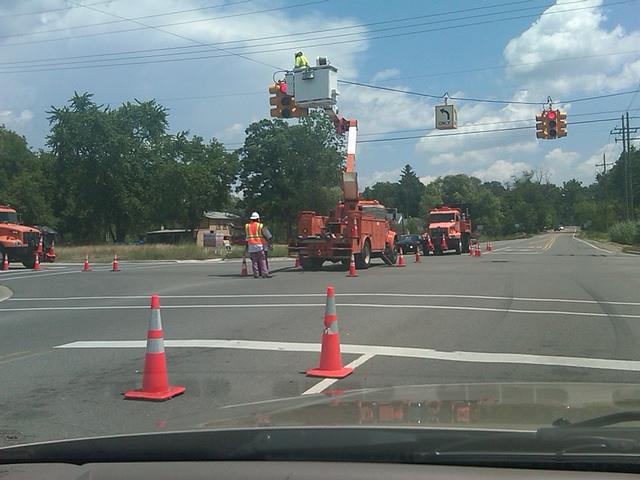What are the men fixing?
Write a very short answer. Lights. Where does the scene take place?
Short answer required. Intersection. Do these guys have a dangerous job?
Short answer required. Yes. 